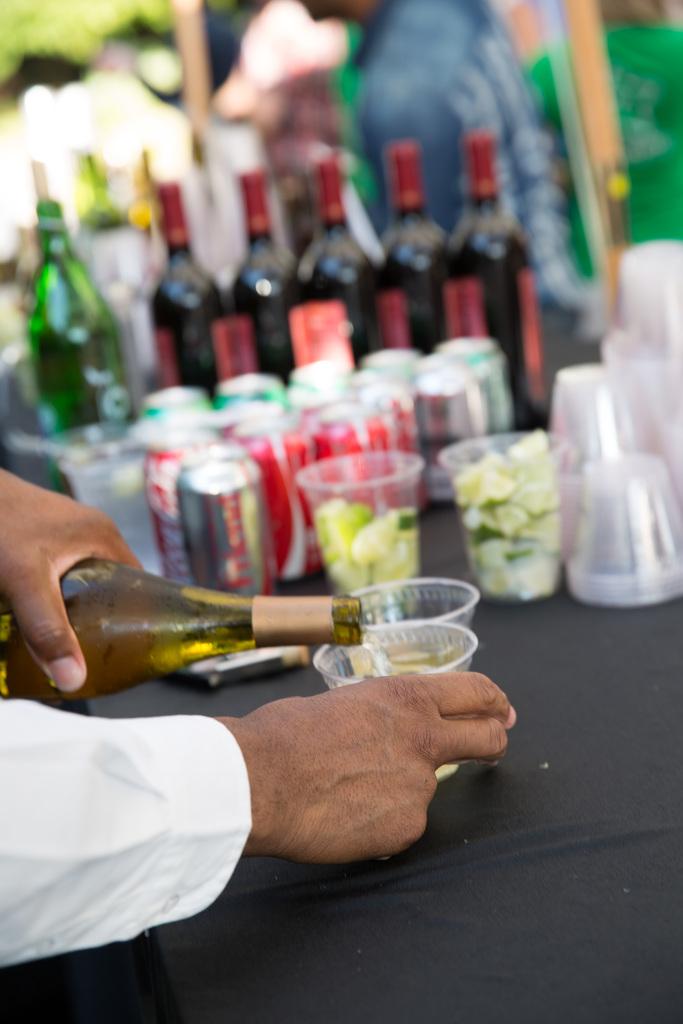What brand of soda is seen?
Ensure brevity in your answer.  Coca-cola. 